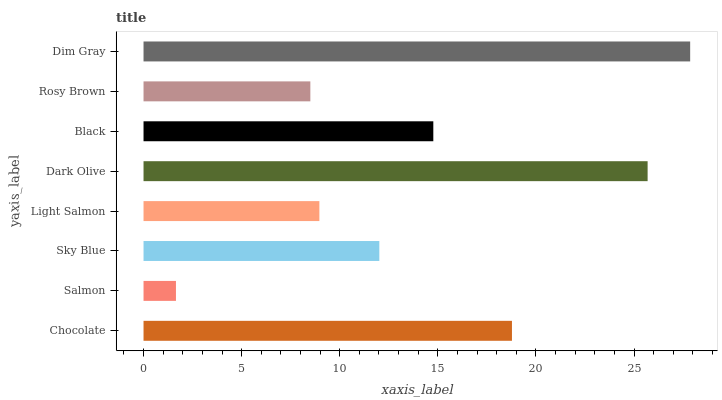Is Salmon the minimum?
Answer yes or no. Yes. Is Dim Gray the maximum?
Answer yes or no. Yes. Is Sky Blue the minimum?
Answer yes or no. No. Is Sky Blue the maximum?
Answer yes or no. No. Is Sky Blue greater than Salmon?
Answer yes or no. Yes. Is Salmon less than Sky Blue?
Answer yes or no. Yes. Is Salmon greater than Sky Blue?
Answer yes or no. No. Is Sky Blue less than Salmon?
Answer yes or no. No. Is Black the high median?
Answer yes or no. Yes. Is Sky Blue the low median?
Answer yes or no. Yes. Is Light Salmon the high median?
Answer yes or no. No. Is Dim Gray the low median?
Answer yes or no. No. 